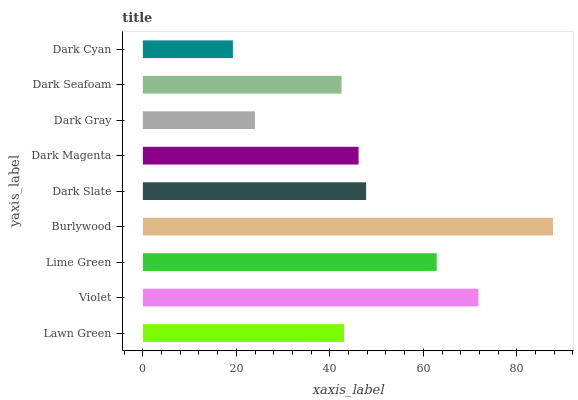Is Dark Cyan the minimum?
Answer yes or no. Yes. Is Burlywood the maximum?
Answer yes or no. Yes. Is Violet the minimum?
Answer yes or no. No. Is Violet the maximum?
Answer yes or no. No. Is Violet greater than Lawn Green?
Answer yes or no. Yes. Is Lawn Green less than Violet?
Answer yes or no. Yes. Is Lawn Green greater than Violet?
Answer yes or no. No. Is Violet less than Lawn Green?
Answer yes or no. No. Is Dark Magenta the high median?
Answer yes or no. Yes. Is Dark Magenta the low median?
Answer yes or no. Yes. Is Burlywood the high median?
Answer yes or no. No. Is Lime Green the low median?
Answer yes or no. No. 